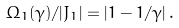<formula> <loc_0><loc_0><loc_500><loc_500>\Omega _ { 1 } ( \gamma ) / | J _ { 1 } | = \left | 1 - 1 / \gamma \right | .</formula> 